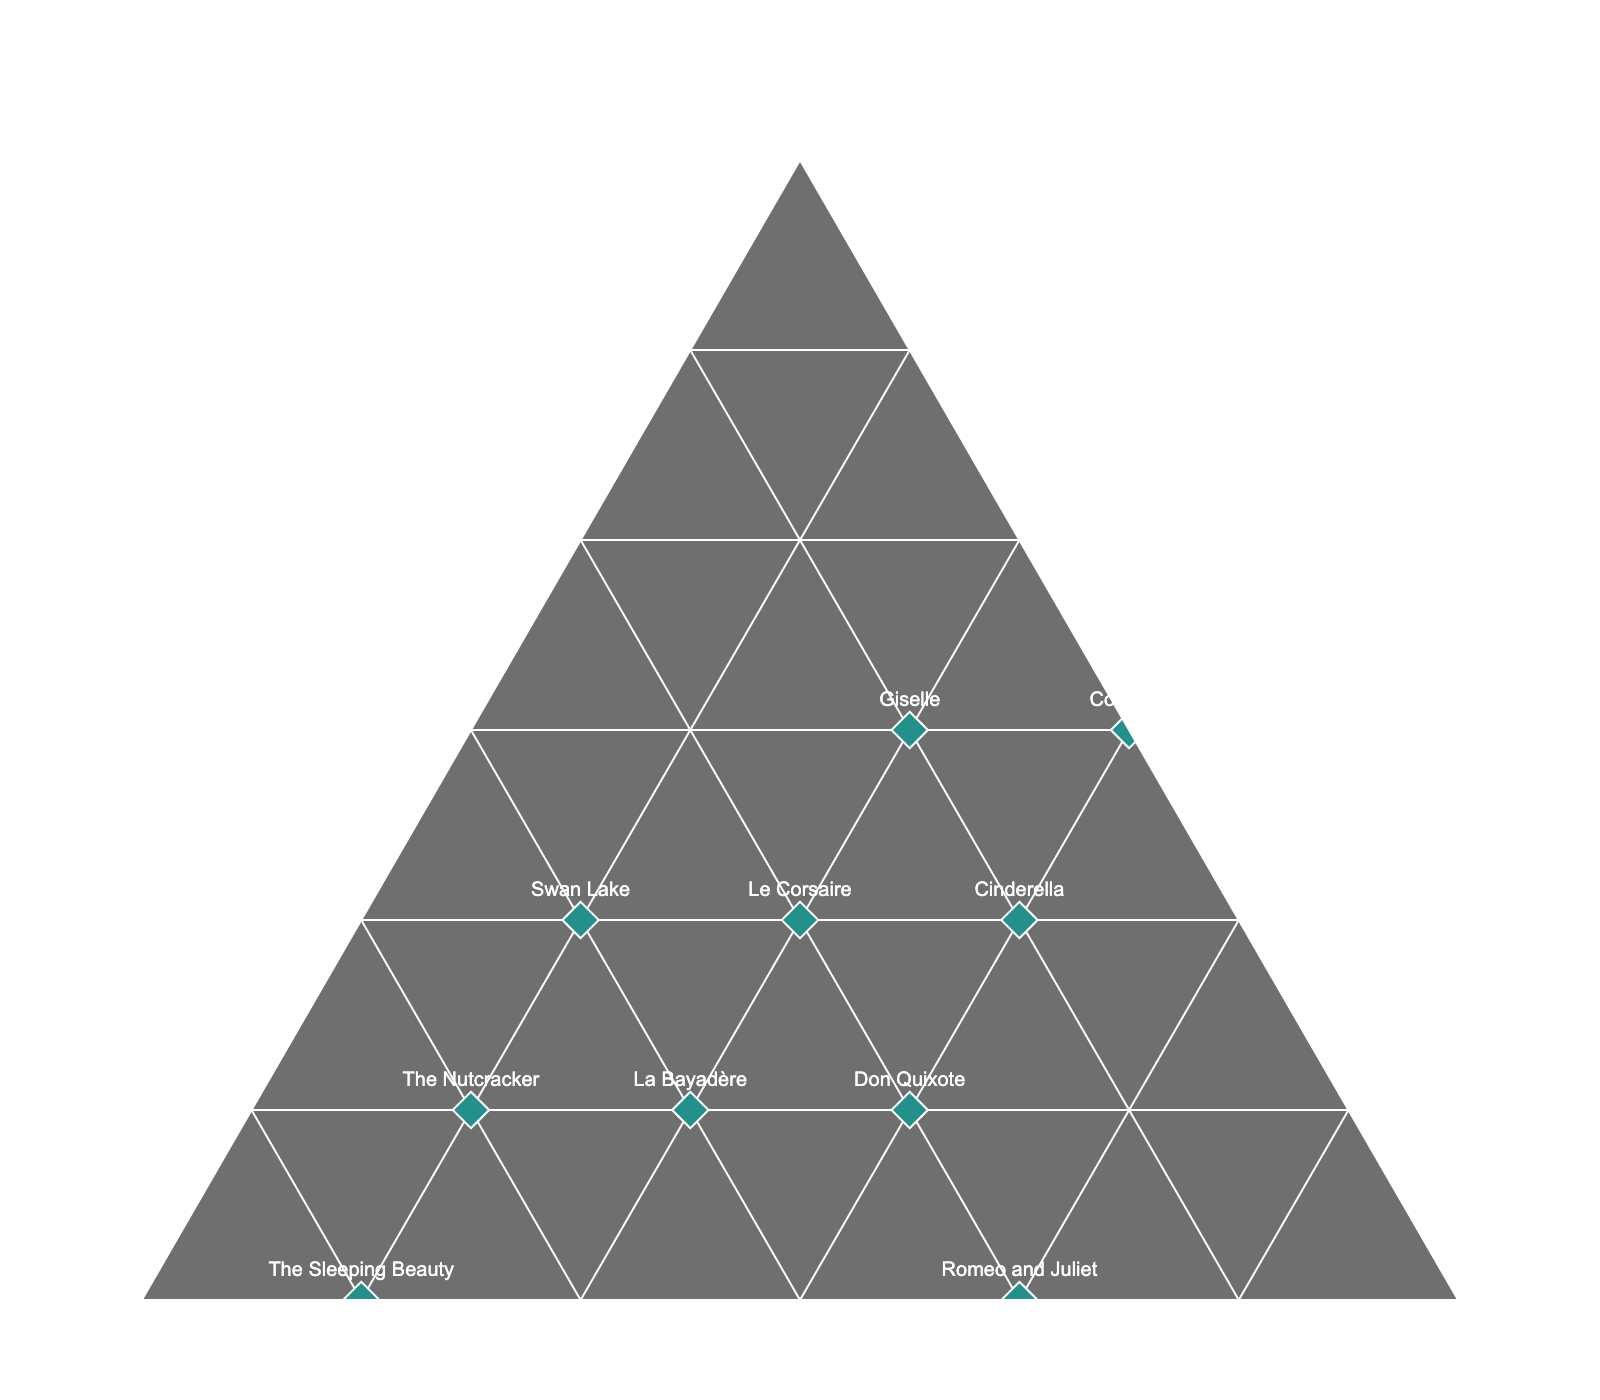What is the title of the plot? The title is typically displayed prominently at the top of the figure.
Answer: Ballet Production Budget Allocation Which production has the highest allocation for Costumes? By looking at the plot, the production closest to the 'Costumes' corner has the highest allocation for Costumes.
Answer: Coppélia How many productions allocate more than 20% of their budget to Marketing? Identify the data points where the Marketing axis shows more than 20%.
Answer: Four (Romeo and Juliet, Don Quixote, Cinderella, Coppélia) Which production has the most balanced budget among Costumes, Sets, and Marketing? The most balanced budget would be closest to the center of the triangle, where each allocation is roughly equal.
Answer: Don Quixote Compare the Costumes allocation between "Swan Lake" and "The Nutcracker." Which production allocates more towards Costumes? Locate both productions on the plot and see which one is closer to the 'Costumes' corner.
Answer: Swan Lake Which two productions have the same Marketing allocation? Find the points along the same line on the 'Marketing' axis.
Answer: Swan Lake and The Nutcracker What is the minimal allocation for Sets in any production? Find the production closest to the 'Sets' axis with minimum values.
Answer: Coppélia (30%) What's the average allocation for Costumes across all productions? Sum the percentages for each production in Costumes and divide by the number of productions (40+35+30+45+35+40+35+30+40+45) / 10.
Answer: 37.5% Is there any production with more than 50% of its budget allocated to any one of the categories? Look for productions nearest one of the three corners.
Answer: The Sleeping Beauty (Sets) Which production has the closest allocation to 50% Costumes and 50% Sets, neglecting Marketing? Find the production nearest the midpoint between the 'Costumes' and 'Sets' corners.
Answer: The Nutcracker 